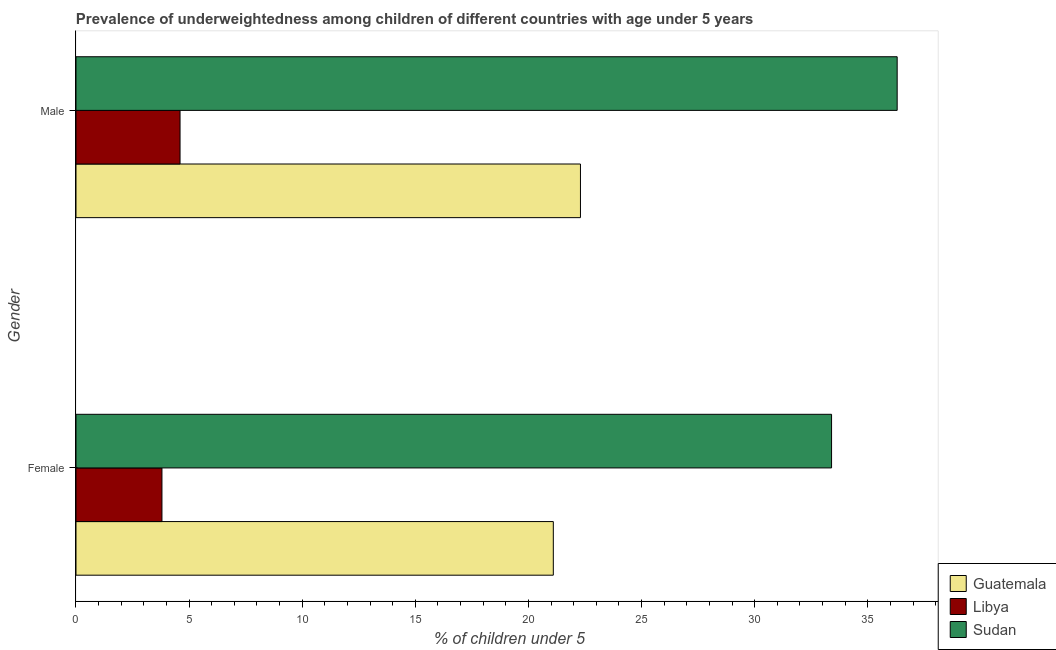How many different coloured bars are there?
Give a very brief answer. 3. How many groups of bars are there?
Your answer should be very brief. 2. Are the number of bars on each tick of the Y-axis equal?
Offer a very short reply. Yes. What is the percentage of underweighted female children in Libya?
Make the answer very short. 3.8. Across all countries, what is the maximum percentage of underweighted male children?
Your response must be concise. 36.3. Across all countries, what is the minimum percentage of underweighted female children?
Offer a very short reply. 3.8. In which country was the percentage of underweighted female children maximum?
Ensure brevity in your answer.  Sudan. In which country was the percentage of underweighted male children minimum?
Your response must be concise. Libya. What is the total percentage of underweighted female children in the graph?
Ensure brevity in your answer.  58.3. What is the difference between the percentage of underweighted male children in Libya and that in Guatemala?
Give a very brief answer. -17.7. What is the difference between the percentage of underweighted female children in Libya and the percentage of underweighted male children in Guatemala?
Your answer should be compact. -18.5. What is the average percentage of underweighted female children per country?
Your answer should be very brief. 19.43. What is the difference between the percentage of underweighted female children and percentage of underweighted male children in Libya?
Your answer should be very brief. -0.8. What is the ratio of the percentage of underweighted female children in Libya to that in Guatemala?
Give a very brief answer. 0.18. Is the percentage of underweighted female children in Libya less than that in Sudan?
Offer a very short reply. Yes. In how many countries, is the percentage of underweighted male children greater than the average percentage of underweighted male children taken over all countries?
Ensure brevity in your answer.  2. What does the 1st bar from the top in Male represents?
Ensure brevity in your answer.  Sudan. What does the 3rd bar from the bottom in Male represents?
Give a very brief answer. Sudan. How many bars are there?
Provide a short and direct response. 6. Are all the bars in the graph horizontal?
Ensure brevity in your answer.  Yes. How many countries are there in the graph?
Ensure brevity in your answer.  3. Are the values on the major ticks of X-axis written in scientific E-notation?
Your answer should be compact. No. Does the graph contain any zero values?
Keep it short and to the point. No. How many legend labels are there?
Your answer should be compact. 3. How are the legend labels stacked?
Your response must be concise. Vertical. What is the title of the graph?
Ensure brevity in your answer.  Prevalence of underweightedness among children of different countries with age under 5 years. What is the label or title of the X-axis?
Offer a terse response.  % of children under 5. What is the label or title of the Y-axis?
Give a very brief answer. Gender. What is the  % of children under 5 of Guatemala in Female?
Your answer should be very brief. 21.1. What is the  % of children under 5 of Libya in Female?
Make the answer very short. 3.8. What is the  % of children under 5 of Sudan in Female?
Your answer should be very brief. 33.4. What is the  % of children under 5 in Guatemala in Male?
Provide a succinct answer. 22.3. What is the  % of children under 5 of Libya in Male?
Make the answer very short. 4.6. What is the  % of children under 5 of Sudan in Male?
Give a very brief answer. 36.3. Across all Gender, what is the maximum  % of children under 5 in Guatemala?
Your answer should be very brief. 22.3. Across all Gender, what is the maximum  % of children under 5 of Libya?
Provide a short and direct response. 4.6. Across all Gender, what is the maximum  % of children under 5 in Sudan?
Your response must be concise. 36.3. Across all Gender, what is the minimum  % of children under 5 of Guatemala?
Offer a very short reply. 21.1. Across all Gender, what is the minimum  % of children under 5 in Libya?
Your answer should be very brief. 3.8. Across all Gender, what is the minimum  % of children under 5 in Sudan?
Your answer should be compact. 33.4. What is the total  % of children under 5 in Guatemala in the graph?
Provide a short and direct response. 43.4. What is the total  % of children under 5 of Sudan in the graph?
Provide a succinct answer. 69.7. What is the difference between the  % of children under 5 in Libya in Female and that in Male?
Your answer should be compact. -0.8. What is the difference between the  % of children under 5 of Sudan in Female and that in Male?
Ensure brevity in your answer.  -2.9. What is the difference between the  % of children under 5 of Guatemala in Female and the  % of children under 5 of Sudan in Male?
Ensure brevity in your answer.  -15.2. What is the difference between the  % of children under 5 in Libya in Female and the  % of children under 5 in Sudan in Male?
Your answer should be compact. -32.5. What is the average  % of children under 5 of Guatemala per Gender?
Ensure brevity in your answer.  21.7. What is the average  % of children under 5 of Sudan per Gender?
Offer a terse response. 34.85. What is the difference between the  % of children under 5 of Guatemala and  % of children under 5 of Libya in Female?
Your answer should be very brief. 17.3. What is the difference between the  % of children under 5 in Guatemala and  % of children under 5 in Sudan in Female?
Make the answer very short. -12.3. What is the difference between the  % of children under 5 in Libya and  % of children under 5 in Sudan in Female?
Your answer should be compact. -29.6. What is the difference between the  % of children under 5 of Libya and  % of children under 5 of Sudan in Male?
Offer a terse response. -31.7. What is the ratio of the  % of children under 5 in Guatemala in Female to that in Male?
Keep it short and to the point. 0.95. What is the ratio of the  % of children under 5 in Libya in Female to that in Male?
Offer a terse response. 0.83. What is the ratio of the  % of children under 5 of Sudan in Female to that in Male?
Provide a short and direct response. 0.92. What is the difference between the highest and the second highest  % of children under 5 of Libya?
Keep it short and to the point. 0.8. What is the difference between the highest and the lowest  % of children under 5 of Libya?
Give a very brief answer. 0.8. What is the difference between the highest and the lowest  % of children under 5 in Sudan?
Make the answer very short. 2.9. 